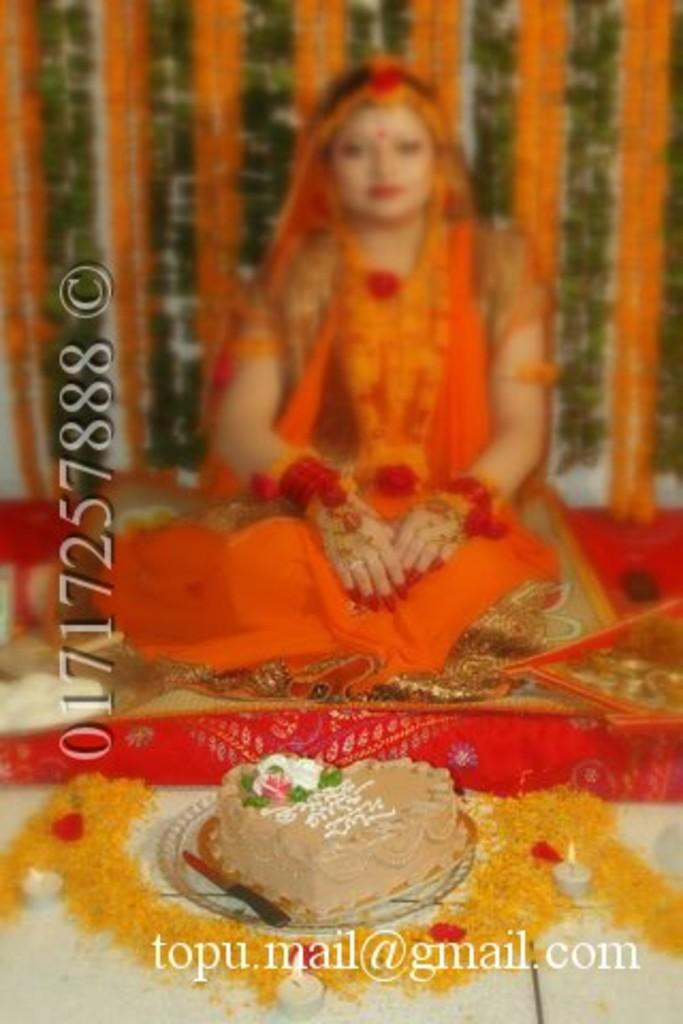What is the main subject of the image? There is a cake in the image. What other objects or elements can be seen in the image? There are flowers, candles, and a person sitting on a carpet in the image. Can you describe the condition of the cake? The cake has candles on it. What is the person sitting on in the image? The person is sitting on a carpet. What type of marble is visible in the frame of the image? There is no marble or frame present in the image. 